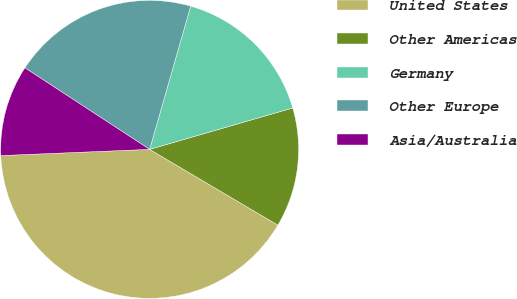<chart> <loc_0><loc_0><loc_500><loc_500><pie_chart><fcel>United States<fcel>Other Americas<fcel>Germany<fcel>Other Europe<fcel>Asia/Australia<nl><fcel>40.84%<fcel>12.98%<fcel>16.07%<fcel>20.23%<fcel>9.88%<nl></chart> 